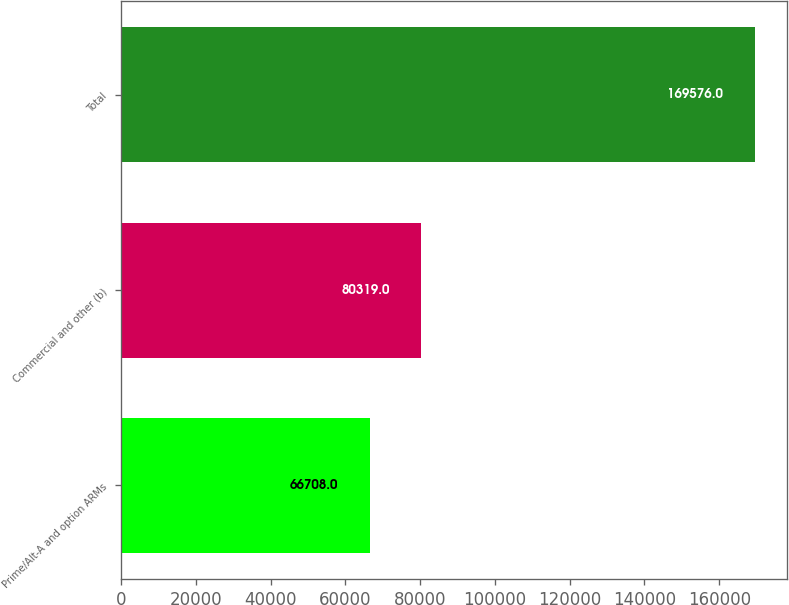Convert chart. <chart><loc_0><loc_0><loc_500><loc_500><bar_chart><fcel>Prime/Alt-A and option ARMs<fcel>Commercial and other (b)<fcel>Total<nl><fcel>66708<fcel>80319<fcel>169576<nl></chart> 